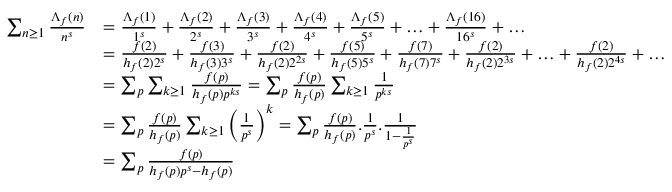Convert formula to latex. <formula><loc_0><loc_0><loc_500><loc_500>\begin{array} { r l } { \sum _ { n \geq 1 } \frac { \Lambda _ { f } ( n ) } { n ^ { s } } } & { = \frac { \Lambda _ { f } ( 1 ) } { 1 ^ { s } } + \frac { \Lambda _ { f } ( 2 ) } { 2 ^ { s } } + \frac { \Lambda _ { f } ( 3 ) } { 3 ^ { s } } + \frac { \Lambda _ { f } ( 4 ) } { 4 ^ { s } } + \frac { \Lambda _ { f } ( 5 ) } { 5 ^ { s } } + \dots + \frac { \Lambda _ { f } ( 1 6 ) } { 1 6 ^ { s } } + \dots } \\ & { = \frac { f ( 2 ) } { h _ { f } ( 2 ) 2 ^ { s } } + \frac { f ( 3 ) } { h _ { f } ( 3 ) 3 ^ { s } } + \frac { f ( 2 ) } { h _ { f } ( 2 ) 2 ^ { 2 s } } + \frac { f ( 5 ) } { h _ { f } ( 5 ) 5 ^ { s } } + \frac { f ( 7 ) } { h _ { f } ( 7 ) 7 ^ { s } } + \frac { f ( 2 ) } { h _ { f } ( 2 ) 2 ^ { 3 s } } + \dots + \frac { f ( 2 ) } { h _ { f } ( 2 ) 2 ^ { 4 s } } + \dots } \\ & { = \sum _ { p } \sum _ { k \geq 1 } \frac { f ( p ) } { h _ { f } ( p ) p ^ { k s } } = \sum _ { p } \frac { f ( p ) } { h _ { f } ( p ) } \sum _ { k \geq 1 } \frac { 1 } { p ^ { k s } } } \\ & { = \sum _ { p } \frac { f ( p ) } { h _ { f } ( p ) } \sum _ { k \geq 1 } \left ( \frac { 1 } { p ^ { s } } \right ) ^ { k } = \sum _ { p } \frac { f ( p ) } { h _ { f } ( p ) } . \frac { 1 } { p ^ { s } } . \frac { 1 } { 1 - \frac { 1 } { p ^ { s } } } } \\ & { = \sum _ { p } \frac { f ( p ) } { h _ { f } ( p ) p ^ { s } - h _ { f } ( p ) } } \end{array}</formula> 